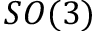Convert formula to latex. <formula><loc_0><loc_0><loc_500><loc_500>S O ( 3 )</formula> 